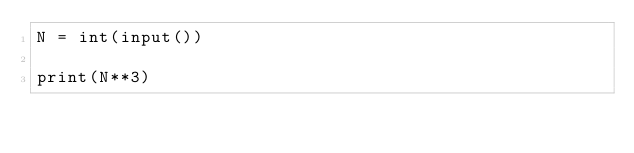Convert code to text. <code><loc_0><loc_0><loc_500><loc_500><_Python_>N = int(input())
  
print(N**3)</code> 